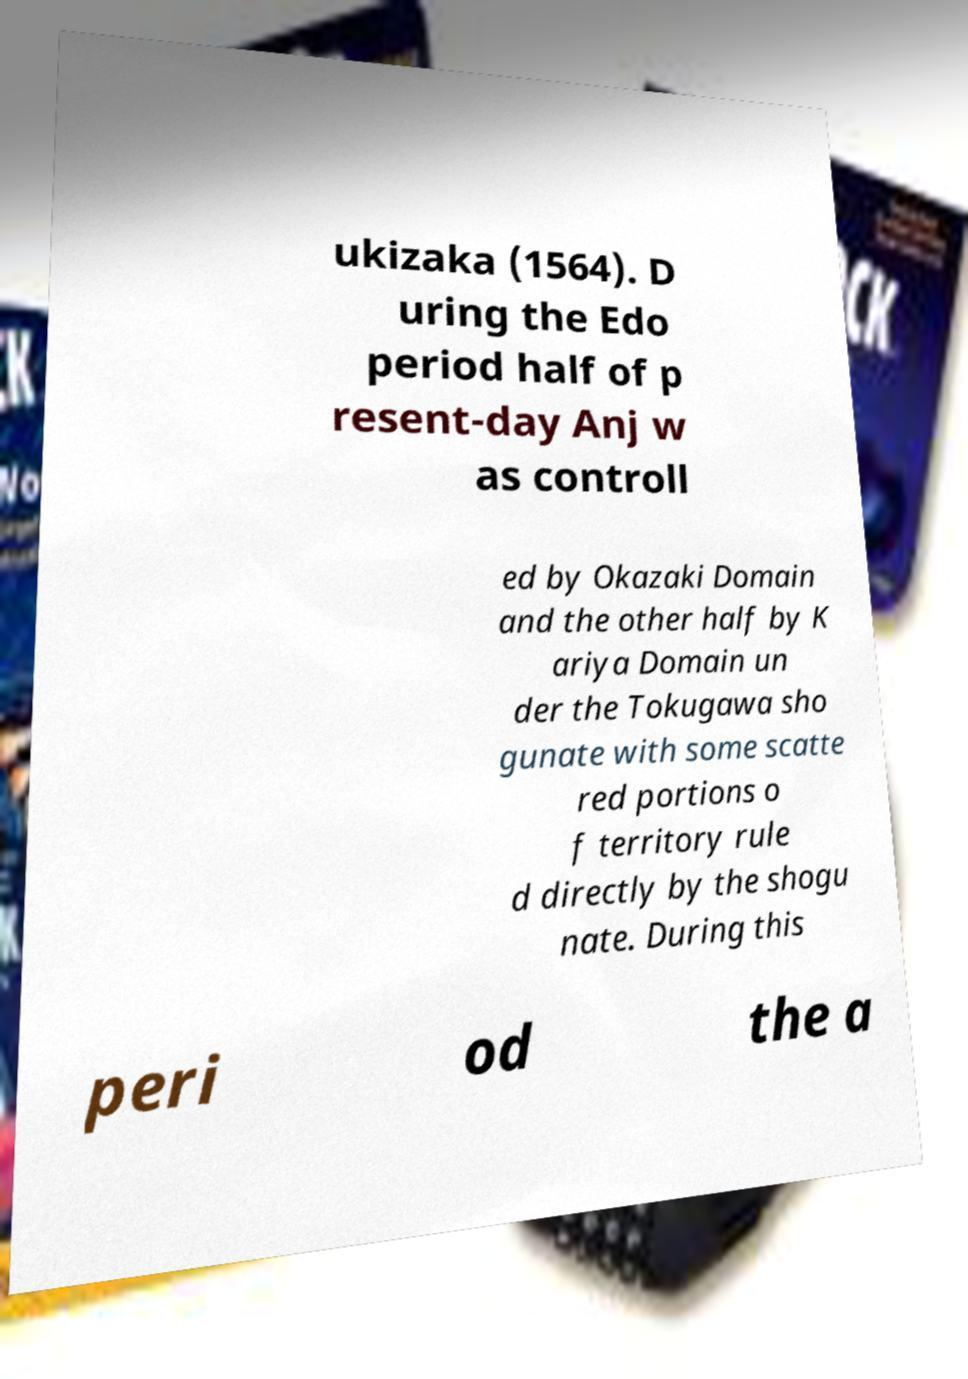There's text embedded in this image that I need extracted. Can you transcribe it verbatim? ukizaka (1564). D uring the Edo period half of p resent-day Anj w as controll ed by Okazaki Domain and the other half by K ariya Domain un der the Tokugawa sho gunate with some scatte red portions o f territory rule d directly by the shogu nate. During this peri od the a 